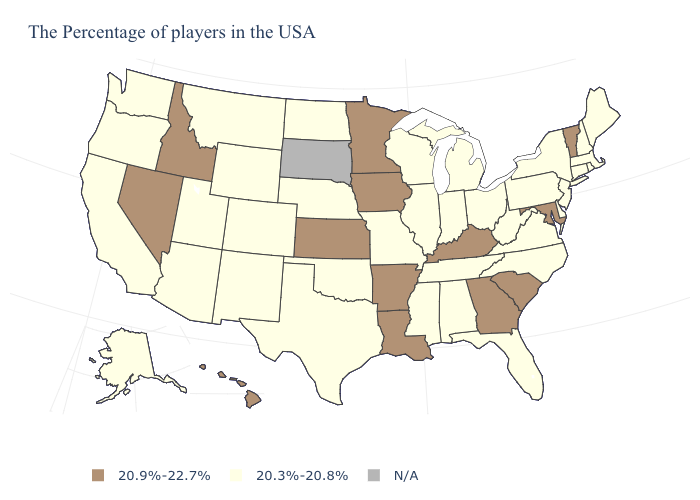Name the states that have a value in the range N/A?
Concise answer only. South Dakota. Which states have the lowest value in the West?
Be succinct. Wyoming, Colorado, New Mexico, Utah, Montana, Arizona, California, Washington, Oregon, Alaska. What is the highest value in states that border Massachusetts?
Short answer required. 20.9%-22.7%. Which states have the lowest value in the USA?
Short answer required. Maine, Massachusetts, Rhode Island, New Hampshire, Connecticut, New York, New Jersey, Delaware, Pennsylvania, Virginia, North Carolina, West Virginia, Ohio, Florida, Michigan, Indiana, Alabama, Tennessee, Wisconsin, Illinois, Mississippi, Missouri, Nebraska, Oklahoma, Texas, North Dakota, Wyoming, Colorado, New Mexico, Utah, Montana, Arizona, California, Washington, Oregon, Alaska. Which states have the lowest value in the USA?
Answer briefly. Maine, Massachusetts, Rhode Island, New Hampshire, Connecticut, New York, New Jersey, Delaware, Pennsylvania, Virginia, North Carolina, West Virginia, Ohio, Florida, Michigan, Indiana, Alabama, Tennessee, Wisconsin, Illinois, Mississippi, Missouri, Nebraska, Oklahoma, Texas, North Dakota, Wyoming, Colorado, New Mexico, Utah, Montana, Arizona, California, Washington, Oregon, Alaska. Name the states that have a value in the range 20.3%-20.8%?
Concise answer only. Maine, Massachusetts, Rhode Island, New Hampshire, Connecticut, New York, New Jersey, Delaware, Pennsylvania, Virginia, North Carolina, West Virginia, Ohio, Florida, Michigan, Indiana, Alabama, Tennessee, Wisconsin, Illinois, Mississippi, Missouri, Nebraska, Oklahoma, Texas, North Dakota, Wyoming, Colorado, New Mexico, Utah, Montana, Arizona, California, Washington, Oregon, Alaska. Name the states that have a value in the range 20.9%-22.7%?
Give a very brief answer. Vermont, Maryland, South Carolina, Georgia, Kentucky, Louisiana, Arkansas, Minnesota, Iowa, Kansas, Idaho, Nevada, Hawaii. Does the map have missing data?
Give a very brief answer. Yes. What is the lowest value in the MidWest?
Answer briefly. 20.3%-20.8%. Name the states that have a value in the range 20.9%-22.7%?
Quick response, please. Vermont, Maryland, South Carolina, Georgia, Kentucky, Louisiana, Arkansas, Minnesota, Iowa, Kansas, Idaho, Nevada, Hawaii. What is the value of South Dakota?
Keep it brief. N/A. Name the states that have a value in the range 20.3%-20.8%?
Concise answer only. Maine, Massachusetts, Rhode Island, New Hampshire, Connecticut, New York, New Jersey, Delaware, Pennsylvania, Virginia, North Carolina, West Virginia, Ohio, Florida, Michigan, Indiana, Alabama, Tennessee, Wisconsin, Illinois, Mississippi, Missouri, Nebraska, Oklahoma, Texas, North Dakota, Wyoming, Colorado, New Mexico, Utah, Montana, Arizona, California, Washington, Oregon, Alaska. Name the states that have a value in the range N/A?
Answer briefly. South Dakota. Does Arizona have the highest value in the USA?
Quick response, please. No. 